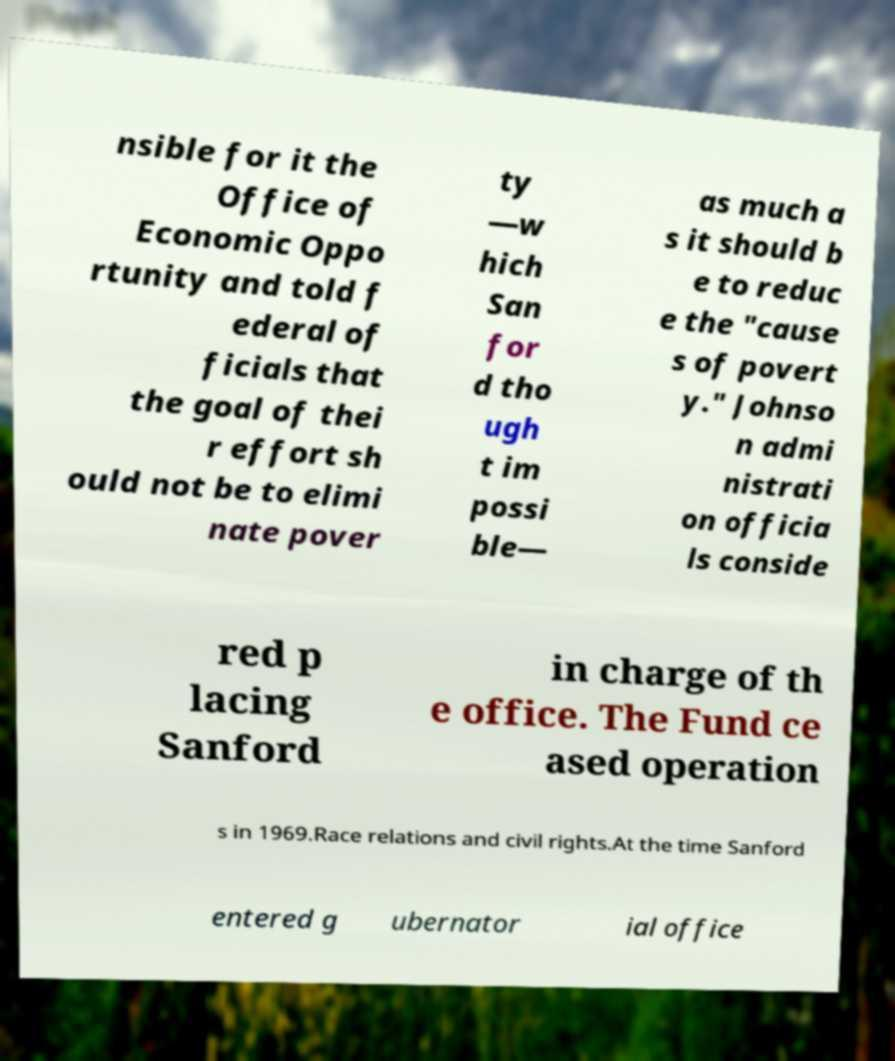Can you accurately transcribe the text from the provided image for me? nsible for it the Office of Economic Oppo rtunity and told f ederal of ficials that the goal of thei r effort sh ould not be to elimi nate pover ty —w hich San for d tho ugh t im possi ble— as much a s it should b e to reduc e the "cause s of povert y." Johnso n admi nistrati on officia ls conside red p lacing Sanford in charge of th e office. The Fund ce ased operation s in 1969.Race relations and civil rights.At the time Sanford entered g ubernator ial office 